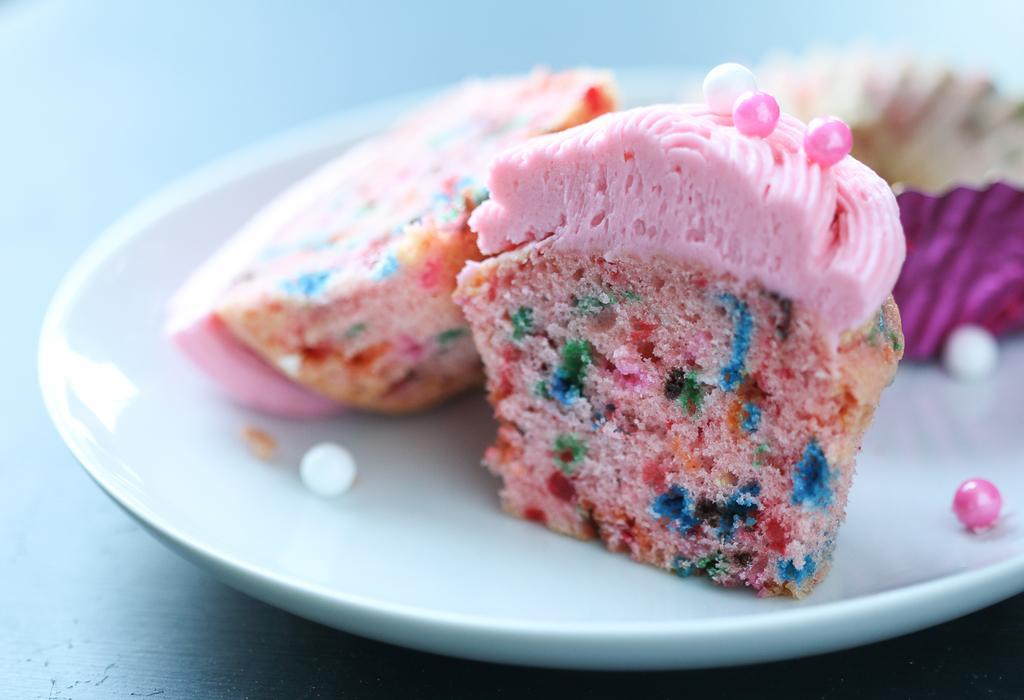Please provide a concise description of this image. In this image I can see pieces of cake in a plate. This image is taken in a room. 